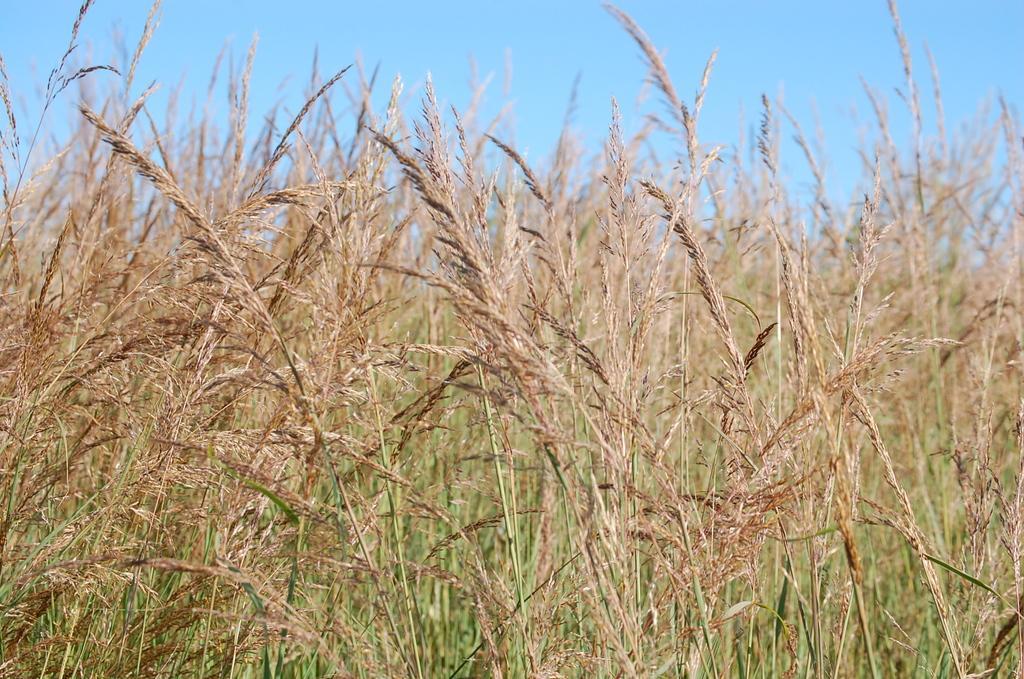Please provide a concise description of this image. In the image in the center, we can see the sky and grass. 